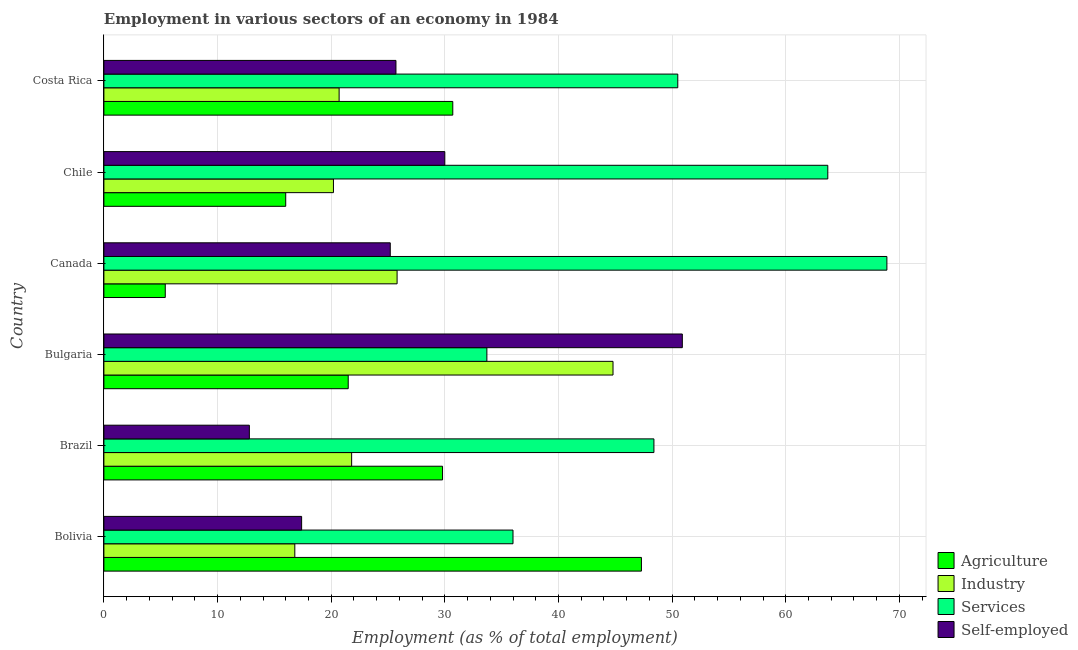How many different coloured bars are there?
Make the answer very short. 4. Are the number of bars per tick equal to the number of legend labels?
Your answer should be compact. Yes. What is the label of the 4th group of bars from the top?
Your answer should be very brief. Bulgaria. What is the percentage of self employed workers in Bolivia?
Offer a very short reply. 17.4. Across all countries, what is the maximum percentage of workers in agriculture?
Provide a short and direct response. 47.3. Across all countries, what is the minimum percentage of self employed workers?
Offer a very short reply. 12.8. In which country was the percentage of self employed workers minimum?
Provide a short and direct response. Brazil. What is the total percentage of workers in industry in the graph?
Your answer should be very brief. 150.1. What is the difference between the percentage of workers in industry in Bolivia and that in Chile?
Your answer should be very brief. -3.4. What is the difference between the percentage of workers in industry in Bolivia and the percentage of workers in services in Chile?
Your answer should be very brief. -46.9. What is the average percentage of workers in industry per country?
Offer a terse response. 25.02. What is the difference between the percentage of workers in agriculture and percentage of workers in industry in Bolivia?
Your answer should be compact. 30.5. What is the ratio of the percentage of workers in services in Bulgaria to that in Costa Rica?
Offer a terse response. 0.67. Is the difference between the percentage of self employed workers in Brazil and Chile greater than the difference between the percentage of workers in agriculture in Brazil and Chile?
Offer a terse response. No. What is the difference between the highest and the second highest percentage of workers in services?
Offer a very short reply. 5.2. What is the difference between the highest and the lowest percentage of workers in industry?
Offer a very short reply. 28. Is it the case that in every country, the sum of the percentage of workers in agriculture and percentage of workers in services is greater than the sum of percentage of self employed workers and percentage of workers in industry?
Offer a very short reply. Yes. What does the 3rd bar from the top in Canada represents?
Keep it short and to the point. Industry. What does the 1st bar from the bottom in Bulgaria represents?
Give a very brief answer. Agriculture. Is it the case that in every country, the sum of the percentage of workers in agriculture and percentage of workers in industry is greater than the percentage of workers in services?
Make the answer very short. No. How many bars are there?
Provide a succinct answer. 24. Are all the bars in the graph horizontal?
Offer a very short reply. Yes. What is the difference between two consecutive major ticks on the X-axis?
Your answer should be compact. 10. Does the graph contain any zero values?
Your response must be concise. No. Does the graph contain grids?
Provide a short and direct response. Yes. What is the title of the graph?
Your answer should be compact. Employment in various sectors of an economy in 1984. What is the label or title of the X-axis?
Your response must be concise. Employment (as % of total employment). What is the Employment (as % of total employment) in Agriculture in Bolivia?
Keep it short and to the point. 47.3. What is the Employment (as % of total employment) of Industry in Bolivia?
Keep it short and to the point. 16.8. What is the Employment (as % of total employment) of Self-employed in Bolivia?
Make the answer very short. 17.4. What is the Employment (as % of total employment) in Agriculture in Brazil?
Provide a short and direct response. 29.8. What is the Employment (as % of total employment) in Industry in Brazil?
Ensure brevity in your answer.  21.8. What is the Employment (as % of total employment) in Services in Brazil?
Ensure brevity in your answer.  48.4. What is the Employment (as % of total employment) of Self-employed in Brazil?
Offer a very short reply. 12.8. What is the Employment (as % of total employment) in Agriculture in Bulgaria?
Offer a terse response. 21.5. What is the Employment (as % of total employment) of Industry in Bulgaria?
Your answer should be compact. 44.8. What is the Employment (as % of total employment) of Services in Bulgaria?
Your answer should be compact. 33.7. What is the Employment (as % of total employment) of Self-employed in Bulgaria?
Provide a succinct answer. 50.9. What is the Employment (as % of total employment) in Agriculture in Canada?
Provide a short and direct response. 5.4. What is the Employment (as % of total employment) of Industry in Canada?
Your answer should be very brief. 25.8. What is the Employment (as % of total employment) of Services in Canada?
Your response must be concise. 68.9. What is the Employment (as % of total employment) in Self-employed in Canada?
Ensure brevity in your answer.  25.2. What is the Employment (as % of total employment) of Industry in Chile?
Keep it short and to the point. 20.2. What is the Employment (as % of total employment) in Services in Chile?
Offer a very short reply. 63.7. What is the Employment (as % of total employment) in Agriculture in Costa Rica?
Offer a terse response. 30.7. What is the Employment (as % of total employment) of Industry in Costa Rica?
Ensure brevity in your answer.  20.7. What is the Employment (as % of total employment) of Services in Costa Rica?
Provide a succinct answer. 50.5. What is the Employment (as % of total employment) in Self-employed in Costa Rica?
Your response must be concise. 25.7. Across all countries, what is the maximum Employment (as % of total employment) of Agriculture?
Ensure brevity in your answer.  47.3. Across all countries, what is the maximum Employment (as % of total employment) of Industry?
Provide a short and direct response. 44.8. Across all countries, what is the maximum Employment (as % of total employment) of Services?
Keep it short and to the point. 68.9. Across all countries, what is the maximum Employment (as % of total employment) in Self-employed?
Your answer should be compact. 50.9. Across all countries, what is the minimum Employment (as % of total employment) of Agriculture?
Ensure brevity in your answer.  5.4. Across all countries, what is the minimum Employment (as % of total employment) in Industry?
Provide a short and direct response. 16.8. Across all countries, what is the minimum Employment (as % of total employment) in Services?
Offer a very short reply. 33.7. Across all countries, what is the minimum Employment (as % of total employment) in Self-employed?
Keep it short and to the point. 12.8. What is the total Employment (as % of total employment) of Agriculture in the graph?
Make the answer very short. 150.7. What is the total Employment (as % of total employment) of Industry in the graph?
Your answer should be compact. 150.1. What is the total Employment (as % of total employment) in Services in the graph?
Your answer should be very brief. 301.2. What is the total Employment (as % of total employment) in Self-employed in the graph?
Offer a very short reply. 162. What is the difference between the Employment (as % of total employment) in Agriculture in Bolivia and that in Brazil?
Give a very brief answer. 17.5. What is the difference between the Employment (as % of total employment) in Industry in Bolivia and that in Brazil?
Your answer should be very brief. -5. What is the difference between the Employment (as % of total employment) of Services in Bolivia and that in Brazil?
Ensure brevity in your answer.  -12.4. What is the difference between the Employment (as % of total employment) of Agriculture in Bolivia and that in Bulgaria?
Your answer should be very brief. 25.8. What is the difference between the Employment (as % of total employment) in Self-employed in Bolivia and that in Bulgaria?
Your response must be concise. -33.5. What is the difference between the Employment (as % of total employment) of Agriculture in Bolivia and that in Canada?
Make the answer very short. 41.9. What is the difference between the Employment (as % of total employment) of Industry in Bolivia and that in Canada?
Provide a succinct answer. -9. What is the difference between the Employment (as % of total employment) of Services in Bolivia and that in Canada?
Your answer should be very brief. -32.9. What is the difference between the Employment (as % of total employment) of Agriculture in Bolivia and that in Chile?
Give a very brief answer. 31.3. What is the difference between the Employment (as % of total employment) in Services in Bolivia and that in Chile?
Your answer should be very brief. -27.7. What is the difference between the Employment (as % of total employment) of Self-employed in Bolivia and that in Chile?
Your answer should be very brief. -12.6. What is the difference between the Employment (as % of total employment) in Services in Bolivia and that in Costa Rica?
Offer a very short reply. -14.5. What is the difference between the Employment (as % of total employment) in Self-employed in Brazil and that in Bulgaria?
Make the answer very short. -38.1. What is the difference between the Employment (as % of total employment) in Agriculture in Brazil and that in Canada?
Make the answer very short. 24.4. What is the difference between the Employment (as % of total employment) of Services in Brazil and that in Canada?
Your answer should be very brief. -20.5. What is the difference between the Employment (as % of total employment) of Industry in Brazil and that in Chile?
Give a very brief answer. 1.6. What is the difference between the Employment (as % of total employment) in Services in Brazil and that in Chile?
Your answer should be very brief. -15.3. What is the difference between the Employment (as % of total employment) in Self-employed in Brazil and that in Chile?
Provide a short and direct response. -17.2. What is the difference between the Employment (as % of total employment) in Agriculture in Brazil and that in Costa Rica?
Your response must be concise. -0.9. What is the difference between the Employment (as % of total employment) in Services in Brazil and that in Costa Rica?
Keep it short and to the point. -2.1. What is the difference between the Employment (as % of total employment) in Self-employed in Brazil and that in Costa Rica?
Your response must be concise. -12.9. What is the difference between the Employment (as % of total employment) of Industry in Bulgaria and that in Canada?
Give a very brief answer. 19. What is the difference between the Employment (as % of total employment) in Services in Bulgaria and that in Canada?
Give a very brief answer. -35.2. What is the difference between the Employment (as % of total employment) in Self-employed in Bulgaria and that in Canada?
Your answer should be compact. 25.7. What is the difference between the Employment (as % of total employment) in Agriculture in Bulgaria and that in Chile?
Your response must be concise. 5.5. What is the difference between the Employment (as % of total employment) in Industry in Bulgaria and that in Chile?
Make the answer very short. 24.6. What is the difference between the Employment (as % of total employment) in Self-employed in Bulgaria and that in Chile?
Ensure brevity in your answer.  20.9. What is the difference between the Employment (as % of total employment) in Industry in Bulgaria and that in Costa Rica?
Make the answer very short. 24.1. What is the difference between the Employment (as % of total employment) in Services in Bulgaria and that in Costa Rica?
Your response must be concise. -16.8. What is the difference between the Employment (as % of total employment) in Self-employed in Bulgaria and that in Costa Rica?
Offer a terse response. 25.2. What is the difference between the Employment (as % of total employment) in Agriculture in Canada and that in Chile?
Give a very brief answer. -10.6. What is the difference between the Employment (as % of total employment) of Industry in Canada and that in Chile?
Keep it short and to the point. 5.6. What is the difference between the Employment (as % of total employment) in Services in Canada and that in Chile?
Keep it short and to the point. 5.2. What is the difference between the Employment (as % of total employment) of Agriculture in Canada and that in Costa Rica?
Ensure brevity in your answer.  -25.3. What is the difference between the Employment (as % of total employment) of Industry in Canada and that in Costa Rica?
Offer a terse response. 5.1. What is the difference between the Employment (as % of total employment) of Agriculture in Chile and that in Costa Rica?
Offer a very short reply. -14.7. What is the difference between the Employment (as % of total employment) in Agriculture in Bolivia and the Employment (as % of total employment) in Services in Brazil?
Offer a terse response. -1.1. What is the difference between the Employment (as % of total employment) in Agriculture in Bolivia and the Employment (as % of total employment) in Self-employed in Brazil?
Your answer should be compact. 34.5. What is the difference between the Employment (as % of total employment) of Industry in Bolivia and the Employment (as % of total employment) of Services in Brazil?
Offer a very short reply. -31.6. What is the difference between the Employment (as % of total employment) of Industry in Bolivia and the Employment (as % of total employment) of Self-employed in Brazil?
Ensure brevity in your answer.  4. What is the difference between the Employment (as % of total employment) in Services in Bolivia and the Employment (as % of total employment) in Self-employed in Brazil?
Provide a short and direct response. 23.2. What is the difference between the Employment (as % of total employment) of Agriculture in Bolivia and the Employment (as % of total employment) of Services in Bulgaria?
Your answer should be compact. 13.6. What is the difference between the Employment (as % of total employment) in Agriculture in Bolivia and the Employment (as % of total employment) in Self-employed in Bulgaria?
Provide a succinct answer. -3.6. What is the difference between the Employment (as % of total employment) in Industry in Bolivia and the Employment (as % of total employment) in Services in Bulgaria?
Offer a very short reply. -16.9. What is the difference between the Employment (as % of total employment) of Industry in Bolivia and the Employment (as % of total employment) of Self-employed in Bulgaria?
Keep it short and to the point. -34.1. What is the difference between the Employment (as % of total employment) in Services in Bolivia and the Employment (as % of total employment) in Self-employed in Bulgaria?
Offer a terse response. -14.9. What is the difference between the Employment (as % of total employment) in Agriculture in Bolivia and the Employment (as % of total employment) in Services in Canada?
Ensure brevity in your answer.  -21.6. What is the difference between the Employment (as % of total employment) of Agriculture in Bolivia and the Employment (as % of total employment) of Self-employed in Canada?
Offer a terse response. 22.1. What is the difference between the Employment (as % of total employment) in Industry in Bolivia and the Employment (as % of total employment) in Services in Canada?
Give a very brief answer. -52.1. What is the difference between the Employment (as % of total employment) in Services in Bolivia and the Employment (as % of total employment) in Self-employed in Canada?
Offer a very short reply. 10.8. What is the difference between the Employment (as % of total employment) in Agriculture in Bolivia and the Employment (as % of total employment) in Industry in Chile?
Your answer should be compact. 27.1. What is the difference between the Employment (as % of total employment) in Agriculture in Bolivia and the Employment (as % of total employment) in Services in Chile?
Your response must be concise. -16.4. What is the difference between the Employment (as % of total employment) in Agriculture in Bolivia and the Employment (as % of total employment) in Self-employed in Chile?
Provide a succinct answer. 17.3. What is the difference between the Employment (as % of total employment) of Industry in Bolivia and the Employment (as % of total employment) of Services in Chile?
Ensure brevity in your answer.  -46.9. What is the difference between the Employment (as % of total employment) in Industry in Bolivia and the Employment (as % of total employment) in Self-employed in Chile?
Offer a terse response. -13.2. What is the difference between the Employment (as % of total employment) in Agriculture in Bolivia and the Employment (as % of total employment) in Industry in Costa Rica?
Provide a succinct answer. 26.6. What is the difference between the Employment (as % of total employment) of Agriculture in Bolivia and the Employment (as % of total employment) of Self-employed in Costa Rica?
Your response must be concise. 21.6. What is the difference between the Employment (as % of total employment) of Industry in Bolivia and the Employment (as % of total employment) of Services in Costa Rica?
Provide a succinct answer. -33.7. What is the difference between the Employment (as % of total employment) in Industry in Bolivia and the Employment (as % of total employment) in Self-employed in Costa Rica?
Offer a terse response. -8.9. What is the difference between the Employment (as % of total employment) of Services in Bolivia and the Employment (as % of total employment) of Self-employed in Costa Rica?
Provide a succinct answer. 10.3. What is the difference between the Employment (as % of total employment) of Agriculture in Brazil and the Employment (as % of total employment) of Industry in Bulgaria?
Your answer should be very brief. -15. What is the difference between the Employment (as % of total employment) of Agriculture in Brazil and the Employment (as % of total employment) of Self-employed in Bulgaria?
Your response must be concise. -21.1. What is the difference between the Employment (as % of total employment) of Industry in Brazil and the Employment (as % of total employment) of Self-employed in Bulgaria?
Your answer should be very brief. -29.1. What is the difference between the Employment (as % of total employment) of Agriculture in Brazil and the Employment (as % of total employment) of Services in Canada?
Offer a terse response. -39.1. What is the difference between the Employment (as % of total employment) of Industry in Brazil and the Employment (as % of total employment) of Services in Canada?
Offer a terse response. -47.1. What is the difference between the Employment (as % of total employment) in Services in Brazil and the Employment (as % of total employment) in Self-employed in Canada?
Provide a succinct answer. 23.2. What is the difference between the Employment (as % of total employment) in Agriculture in Brazil and the Employment (as % of total employment) in Industry in Chile?
Provide a short and direct response. 9.6. What is the difference between the Employment (as % of total employment) in Agriculture in Brazil and the Employment (as % of total employment) in Services in Chile?
Ensure brevity in your answer.  -33.9. What is the difference between the Employment (as % of total employment) of Agriculture in Brazil and the Employment (as % of total employment) of Self-employed in Chile?
Provide a succinct answer. -0.2. What is the difference between the Employment (as % of total employment) of Industry in Brazil and the Employment (as % of total employment) of Services in Chile?
Keep it short and to the point. -41.9. What is the difference between the Employment (as % of total employment) in Agriculture in Brazil and the Employment (as % of total employment) in Industry in Costa Rica?
Provide a succinct answer. 9.1. What is the difference between the Employment (as % of total employment) of Agriculture in Brazil and the Employment (as % of total employment) of Services in Costa Rica?
Make the answer very short. -20.7. What is the difference between the Employment (as % of total employment) of Agriculture in Brazil and the Employment (as % of total employment) of Self-employed in Costa Rica?
Your response must be concise. 4.1. What is the difference between the Employment (as % of total employment) in Industry in Brazil and the Employment (as % of total employment) in Services in Costa Rica?
Provide a short and direct response. -28.7. What is the difference between the Employment (as % of total employment) in Industry in Brazil and the Employment (as % of total employment) in Self-employed in Costa Rica?
Provide a short and direct response. -3.9. What is the difference between the Employment (as % of total employment) of Services in Brazil and the Employment (as % of total employment) of Self-employed in Costa Rica?
Give a very brief answer. 22.7. What is the difference between the Employment (as % of total employment) in Agriculture in Bulgaria and the Employment (as % of total employment) in Services in Canada?
Provide a short and direct response. -47.4. What is the difference between the Employment (as % of total employment) of Industry in Bulgaria and the Employment (as % of total employment) of Services in Canada?
Your response must be concise. -24.1. What is the difference between the Employment (as % of total employment) in Industry in Bulgaria and the Employment (as % of total employment) in Self-employed in Canada?
Make the answer very short. 19.6. What is the difference between the Employment (as % of total employment) in Agriculture in Bulgaria and the Employment (as % of total employment) in Services in Chile?
Give a very brief answer. -42.2. What is the difference between the Employment (as % of total employment) in Industry in Bulgaria and the Employment (as % of total employment) in Services in Chile?
Provide a succinct answer. -18.9. What is the difference between the Employment (as % of total employment) of Industry in Bulgaria and the Employment (as % of total employment) of Self-employed in Costa Rica?
Ensure brevity in your answer.  19.1. What is the difference between the Employment (as % of total employment) of Agriculture in Canada and the Employment (as % of total employment) of Industry in Chile?
Your answer should be very brief. -14.8. What is the difference between the Employment (as % of total employment) of Agriculture in Canada and the Employment (as % of total employment) of Services in Chile?
Give a very brief answer. -58.3. What is the difference between the Employment (as % of total employment) of Agriculture in Canada and the Employment (as % of total employment) of Self-employed in Chile?
Offer a very short reply. -24.6. What is the difference between the Employment (as % of total employment) in Industry in Canada and the Employment (as % of total employment) in Services in Chile?
Ensure brevity in your answer.  -37.9. What is the difference between the Employment (as % of total employment) of Industry in Canada and the Employment (as % of total employment) of Self-employed in Chile?
Provide a short and direct response. -4.2. What is the difference between the Employment (as % of total employment) in Services in Canada and the Employment (as % of total employment) in Self-employed in Chile?
Give a very brief answer. 38.9. What is the difference between the Employment (as % of total employment) of Agriculture in Canada and the Employment (as % of total employment) of Industry in Costa Rica?
Offer a terse response. -15.3. What is the difference between the Employment (as % of total employment) of Agriculture in Canada and the Employment (as % of total employment) of Services in Costa Rica?
Provide a succinct answer. -45.1. What is the difference between the Employment (as % of total employment) in Agriculture in Canada and the Employment (as % of total employment) in Self-employed in Costa Rica?
Keep it short and to the point. -20.3. What is the difference between the Employment (as % of total employment) in Industry in Canada and the Employment (as % of total employment) in Services in Costa Rica?
Your response must be concise. -24.7. What is the difference between the Employment (as % of total employment) in Services in Canada and the Employment (as % of total employment) in Self-employed in Costa Rica?
Ensure brevity in your answer.  43.2. What is the difference between the Employment (as % of total employment) of Agriculture in Chile and the Employment (as % of total employment) of Services in Costa Rica?
Provide a succinct answer. -34.5. What is the difference between the Employment (as % of total employment) of Industry in Chile and the Employment (as % of total employment) of Services in Costa Rica?
Your answer should be compact. -30.3. What is the difference between the Employment (as % of total employment) of Industry in Chile and the Employment (as % of total employment) of Self-employed in Costa Rica?
Your answer should be very brief. -5.5. What is the average Employment (as % of total employment) in Agriculture per country?
Provide a succinct answer. 25.12. What is the average Employment (as % of total employment) of Industry per country?
Keep it short and to the point. 25.02. What is the average Employment (as % of total employment) of Services per country?
Provide a succinct answer. 50.2. What is the average Employment (as % of total employment) of Self-employed per country?
Give a very brief answer. 27. What is the difference between the Employment (as % of total employment) in Agriculture and Employment (as % of total employment) in Industry in Bolivia?
Provide a short and direct response. 30.5. What is the difference between the Employment (as % of total employment) of Agriculture and Employment (as % of total employment) of Self-employed in Bolivia?
Give a very brief answer. 29.9. What is the difference between the Employment (as % of total employment) of Industry and Employment (as % of total employment) of Services in Bolivia?
Your answer should be very brief. -19.2. What is the difference between the Employment (as % of total employment) of Services and Employment (as % of total employment) of Self-employed in Bolivia?
Provide a succinct answer. 18.6. What is the difference between the Employment (as % of total employment) of Agriculture and Employment (as % of total employment) of Services in Brazil?
Your answer should be very brief. -18.6. What is the difference between the Employment (as % of total employment) in Industry and Employment (as % of total employment) in Services in Brazil?
Offer a very short reply. -26.6. What is the difference between the Employment (as % of total employment) of Industry and Employment (as % of total employment) of Self-employed in Brazil?
Keep it short and to the point. 9. What is the difference between the Employment (as % of total employment) of Services and Employment (as % of total employment) of Self-employed in Brazil?
Offer a terse response. 35.6. What is the difference between the Employment (as % of total employment) of Agriculture and Employment (as % of total employment) of Industry in Bulgaria?
Your response must be concise. -23.3. What is the difference between the Employment (as % of total employment) of Agriculture and Employment (as % of total employment) of Self-employed in Bulgaria?
Give a very brief answer. -29.4. What is the difference between the Employment (as % of total employment) of Industry and Employment (as % of total employment) of Services in Bulgaria?
Provide a succinct answer. 11.1. What is the difference between the Employment (as % of total employment) of Industry and Employment (as % of total employment) of Self-employed in Bulgaria?
Offer a very short reply. -6.1. What is the difference between the Employment (as % of total employment) of Services and Employment (as % of total employment) of Self-employed in Bulgaria?
Your answer should be compact. -17.2. What is the difference between the Employment (as % of total employment) of Agriculture and Employment (as % of total employment) of Industry in Canada?
Ensure brevity in your answer.  -20.4. What is the difference between the Employment (as % of total employment) of Agriculture and Employment (as % of total employment) of Services in Canada?
Make the answer very short. -63.5. What is the difference between the Employment (as % of total employment) of Agriculture and Employment (as % of total employment) of Self-employed in Canada?
Give a very brief answer. -19.8. What is the difference between the Employment (as % of total employment) in Industry and Employment (as % of total employment) in Services in Canada?
Your answer should be very brief. -43.1. What is the difference between the Employment (as % of total employment) in Industry and Employment (as % of total employment) in Self-employed in Canada?
Make the answer very short. 0.6. What is the difference between the Employment (as % of total employment) in Services and Employment (as % of total employment) in Self-employed in Canada?
Your response must be concise. 43.7. What is the difference between the Employment (as % of total employment) in Agriculture and Employment (as % of total employment) in Industry in Chile?
Your answer should be very brief. -4.2. What is the difference between the Employment (as % of total employment) in Agriculture and Employment (as % of total employment) in Services in Chile?
Offer a very short reply. -47.7. What is the difference between the Employment (as % of total employment) of Industry and Employment (as % of total employment) of Services in Chile?
Keep it short and to the point. -43.5. What is the difference between the Employment (as % of total employment) of Industry and Employment (as % of total employment) of Self-employed in Chile?
Your answer should be very brief. -9.8. What is the difference between the Employment (as % of total employment) in Services and Employment (as % of total employment) in Self-employed in Chile?
Provide a short and direct response. 33.7. What is the difference between the Employment (as % of total employment) of Agriculture and Employment (as % of total employment) of Services in Costa Rica?
Your answer should be compact. -19.8. What is the difference between the Employment (as % of total employment) in Industry and Employment (as % of total employment) in Services in Costa Rica?
Offer a terse response. -29.8. What is the difference between the Employment (as % of total employment) in Services and Employment (as % of total employment) in Self-employed in Costa Rica?
Your answer should be compact. 24.8. What is the ratio of the Employment (as % of total employment) in Agriculture in Bolivia to that in Brazil?
Make the answer very short. 1.59. What is the ratio of the Employment (as % of total employment) of Industry in Bolivia to that in Brazil?
Provide a succinct answer. 0.77. What is the ratio of the Employment (as % of total employment) of Services in Bolivia to that in Brazil?
Offer a terse response. 0.74. What is the ratio of the Employment (as % of total employment) of Self-employed in Bolivia to that in Brazil?
Give a very brief answer. 1.36. What is the ratio of the Employment (as % of total employment) of Agriculture in Bolivia to that in Bulgaria?
Offer a terse response. 2.2. What is the ratio of the Employment (as % of total employment) of Services in Bolivia to that in Bulgaria?
Make the answer very short. 1.07. What is the ratio of the Employment (as % of total employment) of Self-employed in Bolivia to that in Bulgaria?
Provide a short and direct response. 0.34. What is the ratio of the Employment (as % of total employment) in Agriculture in Bolivia to that in Canada?
Ensure brevity in your answer.  8.76. What is the ratio of the Employment (as % of total employment) of Industry in Bolivia to that in Canada?
Make the answer very short. 0.65. What is the ratio of the Employment (as % of total employment) of Services in Bolivia to that in Canada?
Provide a short and direct response. 0.52. What is the ratio of the Employment (as % of total employment) in Self-employed in Bolivia to that in Canada?
Ensure brevity in your answer.  0.69. What is the ratio of the Employment (as % of total employment) in Agriculture in Bolivia to that in Chile?
Keep it short and to the point. 2.96. What is the ratio of the Employment (as % of total employment) in Industry in Bolivia to that in Chile?
Your answer should be very brief. 0.83. What is the ratio of the Employment (as % of total employment) in Services in Bolivia to that in Chile?
Offer a very short reply. 0.57. What is the ratio of the Employment (as % of total employment) in Self-employed in Bolivia to that in Chile?
Offer a terse response. 0.58. What is the ratio of the Employment (as % of total employment) in Agriculture in Bolivia to that in Costa Rica?
Give a very brief answer. 1.54. What is the ratio of the Employment (as % of total employment) of Industry in Bolivia to that in Costa Rica?
Offer a terse response. 0.81. What is the ratio of the Employment (as % of total employment) of Services in Bolivia to that in Costa Rica?
Provide a succinct answer. 0.71. What is the ratio of the Employment (as % of total employment) in Self-employed in Bolivia to that in Costa Rica?
Your answer should be very brief. 0.68. What is the ratio of the Employment (as % of total employment) of Agriculture in Brazil to that in Bulgaria?
Provide a short and direct response. 1.39. What is the ratio of the Employment (as % of total employment) in Industry in Brazil to that in Bulgaria?
Ensure brevity in your answer.  0.49. What is the ratio of the Employment (as % of total employment) in Services in Brazil to that in Bulgaria?
Provide a short and direct response. 1.44. What is the ratio of the Employment (as % of total employment) of Self-employed in Brazil to that in Bulgaria?
Give a very brief answer. 0.25. What is the ratio of the Employment (as % of total employment) of Agriculture in Brazil to that in Canada?
Give a very brief answer. 5.52. What is the ratio of the Employment (as % of total employment) in Industry in Brazil to that in Canada?
Give a very brief answer. 0.84. What is the ratio of the Employment (as % of total employment) in Services in Brazil to that in Canada?
Offer a terse response. 0.7. What is the ratio of the Employment (as % of total employment) of Self-employed in Brazil to that in Canada?
Your response must be concise. 0.51. What is the ratio of the Employment (as % of total employment) of Agriculture in Brazil to that in Chile?
Give a very brief answer. 1.86. What is the ratio of the Employment (as % of total employment) of Industry in Brazil to that in Chile?
Make the answer very short. 1.08. What is the ratio of the Employment (as % of total employment) of Services in Brazil to that in Chile?
Your answer should be compact. 0.76. What is the ratio of the Employment (as % of total employment) of Self-employed in Brazil to that in Chile?
Your answer should be compact. 0.43. What is the ratio of the Employment (as % of total employment) in Agriculture in Brazil to that in Costa Rica?
Ensure brevity in your answer.  0.97. What is the ratio of the Employment (as % of total employment) of Industry in Brazil to that in Costa Rica?
Provide a short and direct response. 1.05. What is the ratio of the Employment (as % of total employment) of Services in Brazil to that in Costa Rica?
Give a very brief answer. 0.96. What is the ratio of the Employment (as % of total employment) in Self-employed in Brazil to that in Costa Rica?
Your response must be concise. 0.5. What is the ratio of the Employment (as % of total employment) in Agriculture in Bulgaria to that in Canada?
Provide a succinct answer. 3.98. What is the ratio of the Employment (as % of total employment) in Industry in Bulgaria to that in Canada?
Offer a terse response. 1.74. What is the ratio of the Employment (as % of total employment) of Services in Bulgaria to that in Canada?
Your answer should be very brief. 0.49. What is the ratio of the Employment (as % of total employment) of Self-employed in Bulgaria to that in Canada?
Make the answer very short. 2.02. What is the ratio of the Employment (as % of total employment) in Agriculture in Bulgaria to that in Chile?
Provide a short and direct response. 1.34. What is the ratio of the Employment (as % of total employment) of Industry in Bulgaria to that in Chile?
Ensure brevity in your answer.  2.22. What is the ratio of the Employment (as % of total employment) in Services in Bulgaria to that in Chile?
Give a very brief answer. 0.53. What is the ratio of the Employment (as % of total employment) of Self-employed in Bulgaria to that in Chile?
Offer a terse response. 1.7. What is the ratio of the Employment (as % of total employment) in Agriculture in Bulgaria to that in Costa Rica?
Make the answer very short. 0.7. What is the ratio of the Employment (as % of total employment) of Industry in Bulgaria to that in Costa Rica?
Your answer should be compact. 2.16. What is the ratio of the Employment (as % of total employment) of Services in Bulgaria to that in Costa Rica?
Your answer should be very brief. 0.67. What is the ratio of the Employment (as % of total employment) in Self-employed in Bulgaria to that in Costa Rica?
Give a very brief answer. 1.98. What is the ratio of the Employment (as % of total employment) of Agriculture in Canada to that in Chile?
Keep it short and to the point. 0.34. What is the ratio of the Employment (as % of total employment) in Industry in Canada to that in Chile?
Your response must be concise. 1.28. What is the ratio of the Employment (as % of total employment) of Services in Canada to that in Chile?
Provide a short and direct response. 1.08. What is the ratio of the Employment (as % of total employment) of Self-employed in Canada to that in Chile?
Your response must be concise. 0.84. What is the ratio of the Employment (as % of total employment) of Agriculture in Canada to that in Costa Rica?
Provide a succinct answer. 0.18. What is the ratio of the Employment (as % of total employment) in Industry in Canada to that in Costa Rica?
Keep it short and to the point. 1.25. What is the ratio of the Employment (as % of total employment) in Services in Canada to that in Costa Rica?
Your response must be concise. 1.36. What is the ratio of the Employment (as % of total employment) of Self-employed in Canada to that in Costa Rica?
Ensure brevity in your answer.  0.98. What is the ratio of the Employment (as % of total employment) of Agriculture in Chile to that in Costa Rica?
Your answer should be compact. 0.52. What is the ratio of the Employment (as % of total employment) of Industry in Chile to that in Costa Rica?
Provide a short and direct response. 0.98. What is the ratio of the Employment (as % of total employment) of Services in Chile to that in Costa Rica?
Give a very brief answer. 1.26. What is the ratio of the Employment (as % of total employment) of Self-employed in Chile to that in Costa Rica?
Offer a very short reply. 1.17. What is the difference between the highest and the second highest Employment (as % of total employment) in Agriculture?
Provide a succinct answer. 16.6. What is the difference between the highest and the second highest Employment (as % of total employment) in Services?
Your response must be concise. 5.2. What is the difference between the highest and the second highest Employment (as % of total employment) in Self-employed?
Give a very brief answer. 20.9. What is the difference between the highest and the lowest Employment (as % of total employment) in Agriculture?
Your answer should be very brief. 41.9. What is the difference between the highest and the lowest Employment (as % of total employment) in Industry?
Ensure brevity in your answer.  28. What is the difference between the highest and the lowest Employment (as % of total employment) of Services?
Your answer should be very brief. 35.2. What is the difference between the highest and the lowest Employment (as % of total employment) of Self-employed?
Your response must be concise. 38.1. 